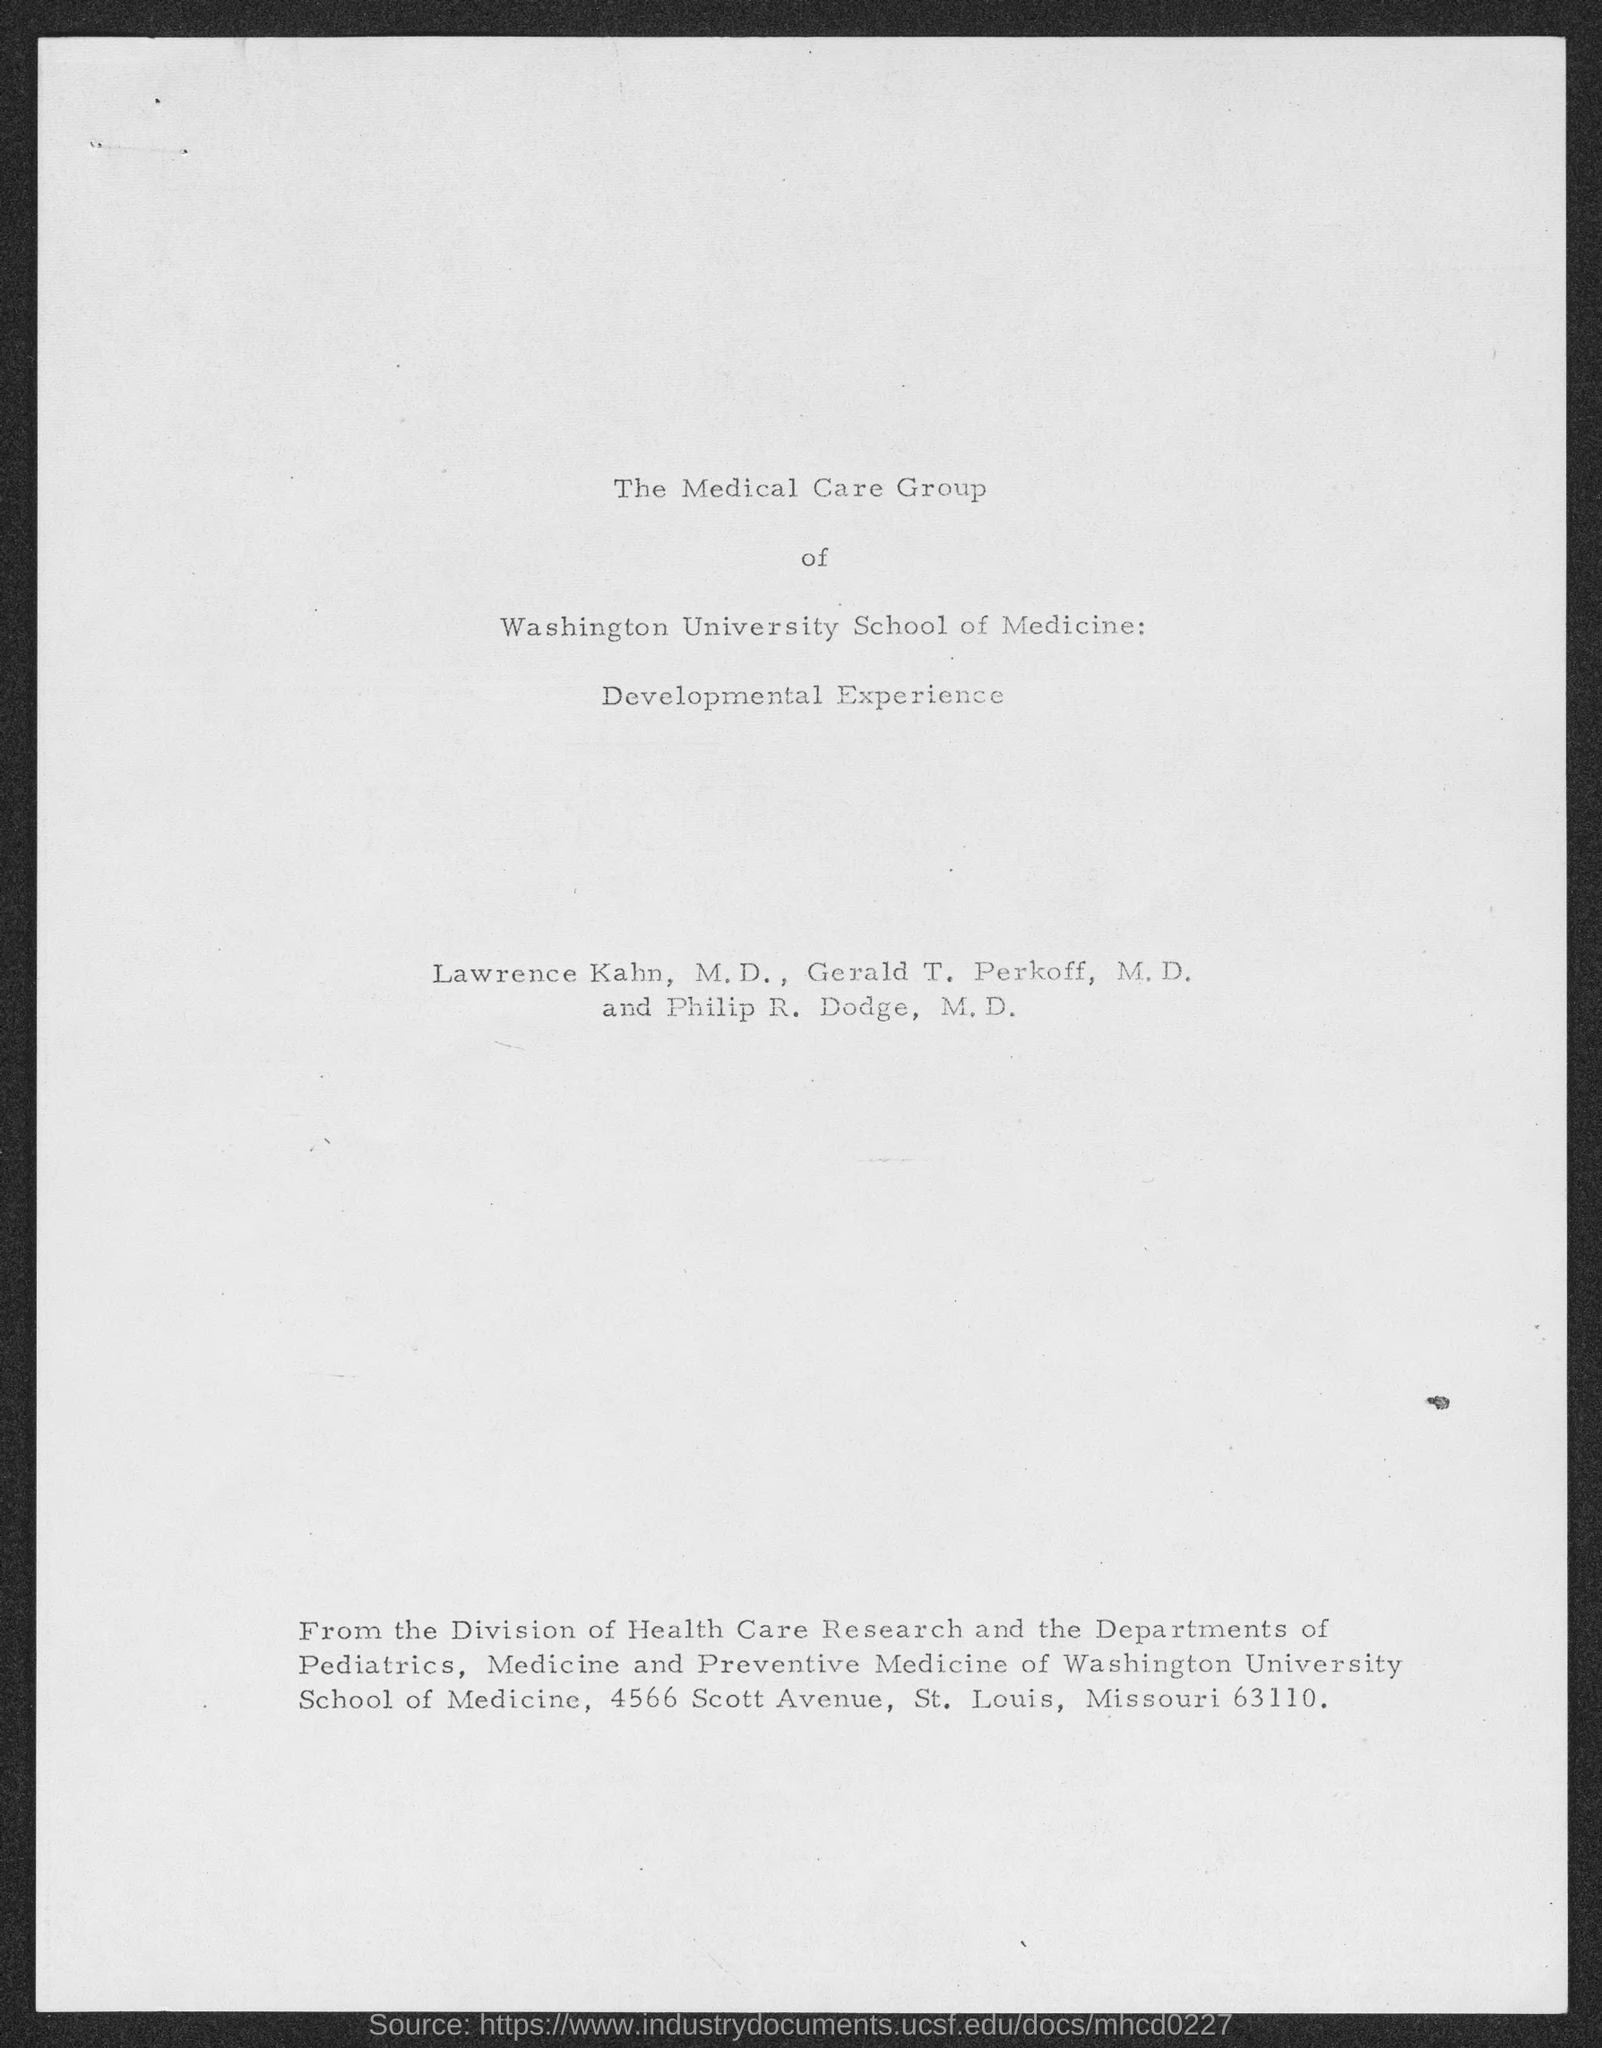What is the street address of medicine and preventive medicine of washington university school of medicine ?
Ensure brevity in your answer.  4566 Scott Avenue, St. Louis, Missouri 63110. 